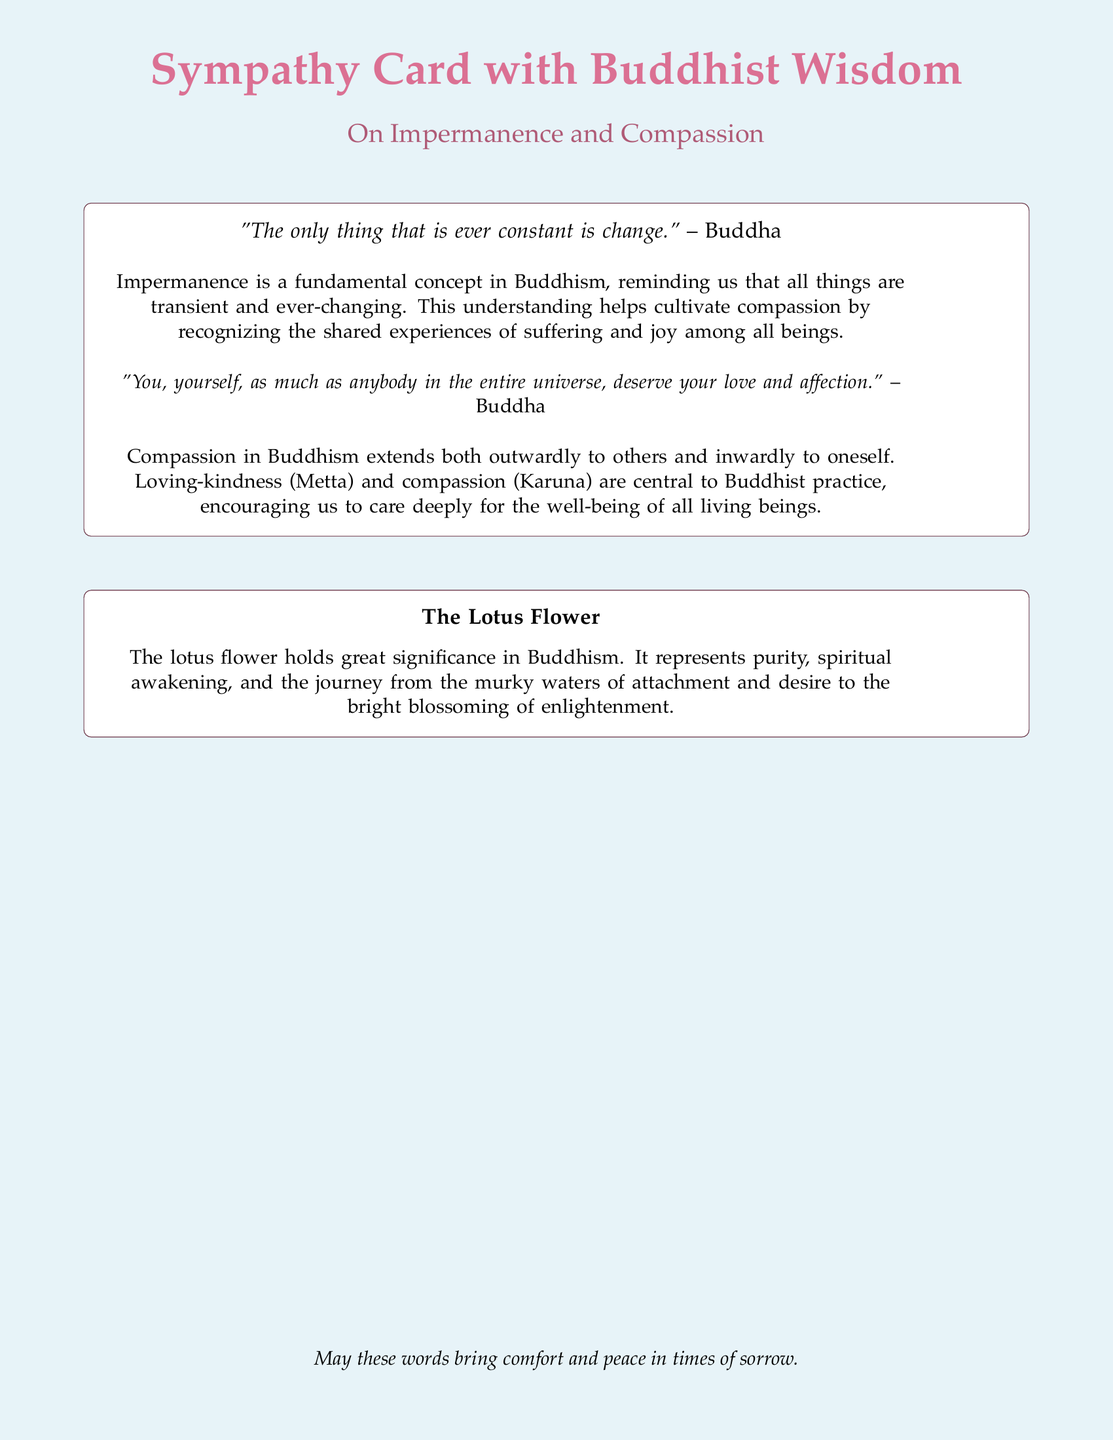What is the title of the card? The title of the card is prominently displayed at the top of the document.
Answer: Sympathy Card with Buddhist Wisdom What color represents the lotus in the document? The lotus color is defined at the beginning of the code using RGB values.
Answer: RGB(219,112,147) What are the two central concepts mentioned in the document? The concepts are specifically highlighted in the descriptions provided in the text.
Answer: Impermanence and Compassion Who is quoted in the card? The quotes are attributed to a specific historical figure in Buddhism.
Answer: Buddha What does the lotus flower represent in Buddhism? The document includes a definition of the symbolic meaning of the lotus flower.
Answer: Purity, spiritual awakening, and enlightenment What is the primary purpose of the card? The intention behind the card's design and content is indicated at the bottom of the document.
Answer: To bring comfort and peace in times of sorrow How does the document describe compassion? The text elaborates on the nature of compassion as it relates to Buddhist practice.
Answer: Loving-kindness (Metta) and compassion (Karuna) In which part of the card do we find the quotes? The quotes are contained within a specific section that holds meaningful reflections.
Answer: In the tikzpicture node 